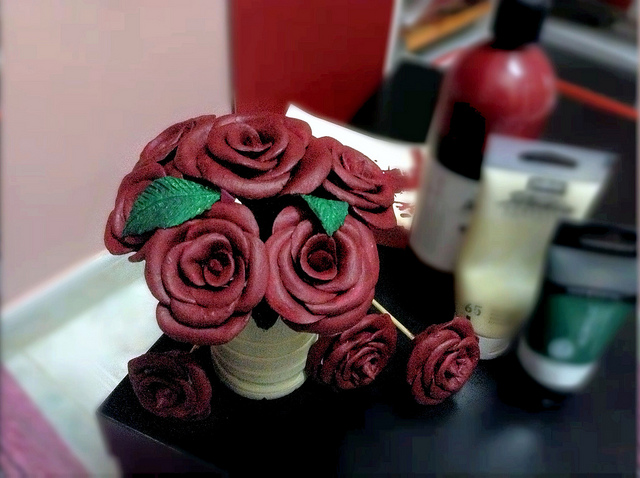<image>What flower is with the rose? It is ambiguous. There is no flower with the rose but there can be leaves or other roses. What flower is with the rose? I am not sure what flower is with the rose. It can be seen green leaves, roses, or other roses. 